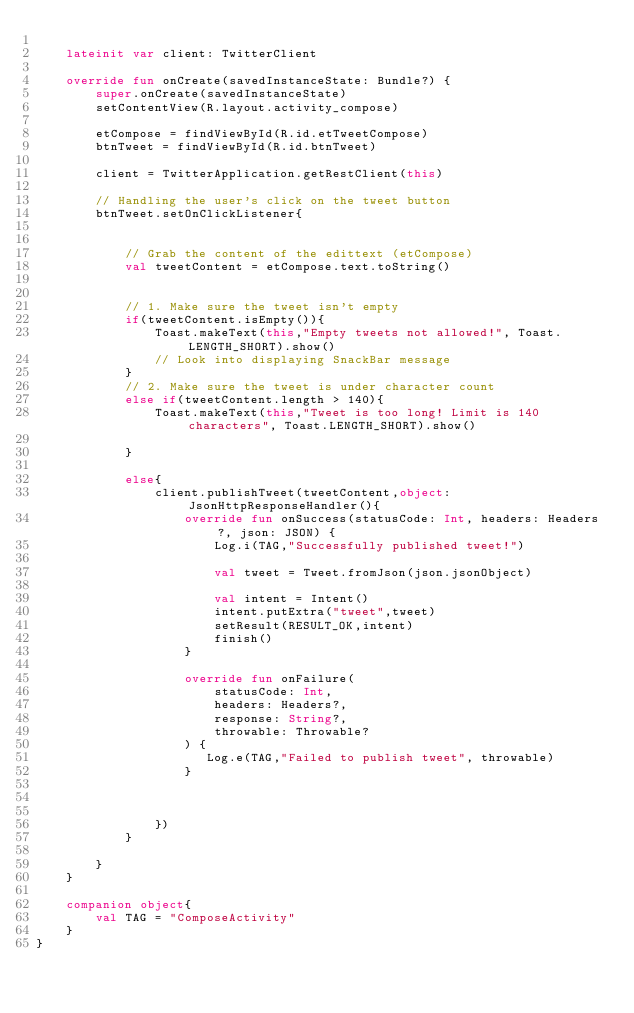<code> <loc_0><loc_0><loc_500><loc_500><_Kotlin_>
    lateinit var client: TwitterClient

    override fun onCreate(savedInstanceState: Bundle?) {
        super.onCreate(savedInstanceState)
        setContentView(R.layout.activity_compose)

        etCompose = findViewById(R.id.etTweetCompose)
        btnTweet = findViewById(R.id.btnTweet)

        client = TwitterApplication.getRestClient(this)

        // Handling the user's click on the tweet button
        btnTweet.setOnClickListener{


            // Grab the content of the edittext (etCompose)
            val tweetContent = etCompose.text.toString()


            // 1. Make sure the tweet isn't empty
            if(tweetContent.isEmpty()){
                Toast.makeText(this,"Empty tweets not allowed!", Toast.LENGTH_SHORT).show()
                // Look into displaying SnackBar message
            }
            // 2. Make sure the tweet is under character count
            else if(tweetContent.length > 140){
                Toast.makeText(this,"Tweet is too long! Limit is 140 characters", Toast.LENGTH_SHORT).show()

            }

            else{
                client.publishTweet(tweetContent,object: JsonHttpResponseHandler(){
                    override fun onSuccess(statusCode: Int, headers: Headers?, json: JSON) {
                        Log.i(TAG,"Successfully published tweet!")

                        val tweet = Tweet.fromJson(json.jsonObject)

                        val intent = Intent()
                        intent.putExtra("tweet",tweet)
                        setResult(RESULT_OK,intent)
                        finish()
                    }

                    override fun onFailure(
                        statusCode: Int,
                        headers: Headers?,
                        response: String?,
                        throwable: Throwable?
                    ) {
                       Log.e(TAG,"Failed to publish tweet", throwable)
                    }



                })
            }

        }
    }

    companion object{
        val TAG = "ComposeActivity"
    }
}</code> 